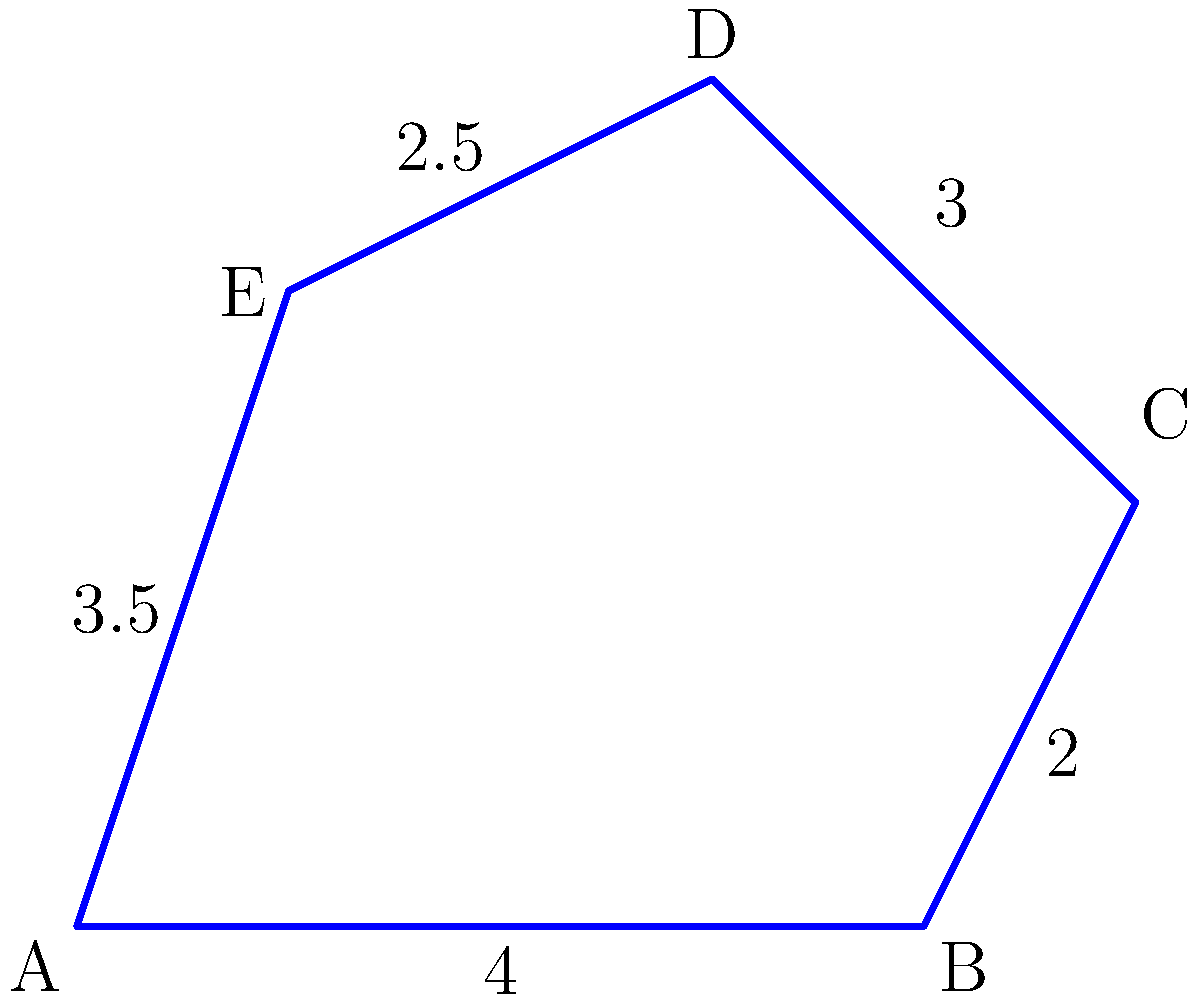A new phone grip accessory for HTC devices has been designed with an irregular pentagon shape. The lengths of four sides are known: AB = 4 cm, BC = 2 cm, CD = 3 cm, and DE = 2.5 cm. If the perimeter of the entire shape is 15 cm, what is the length of side EA? To find the length of side EA, we can follow these steps:

1. Identify the known information:
   - The shape is an irregular pentagon
   - AB = 4 cm
   - BC = 2 cm
   - CD = 3 cm
   - DE = 2.5 cm
   - Total perimeter = 15 cm

2. Calculate the sum of the known sides:
   $4 + 2 + 3 + 2.5 = 11.5$ cm

3. Use the perimeter formula for a pentagon:
   Perimeter = AB + BC + CD + DE + EA

4. Substitute the known values:
   $15 = 4 + 2 + 3 + 2.5 + EA$

5. Solve for EA:
   $15 = 11.5 + EA$
   $EA = 15 - 11.5$
   $EA = 3.5$ cm

Therefore, the length of side EA is 3.5 cm.
Answer: 3.5 cm 